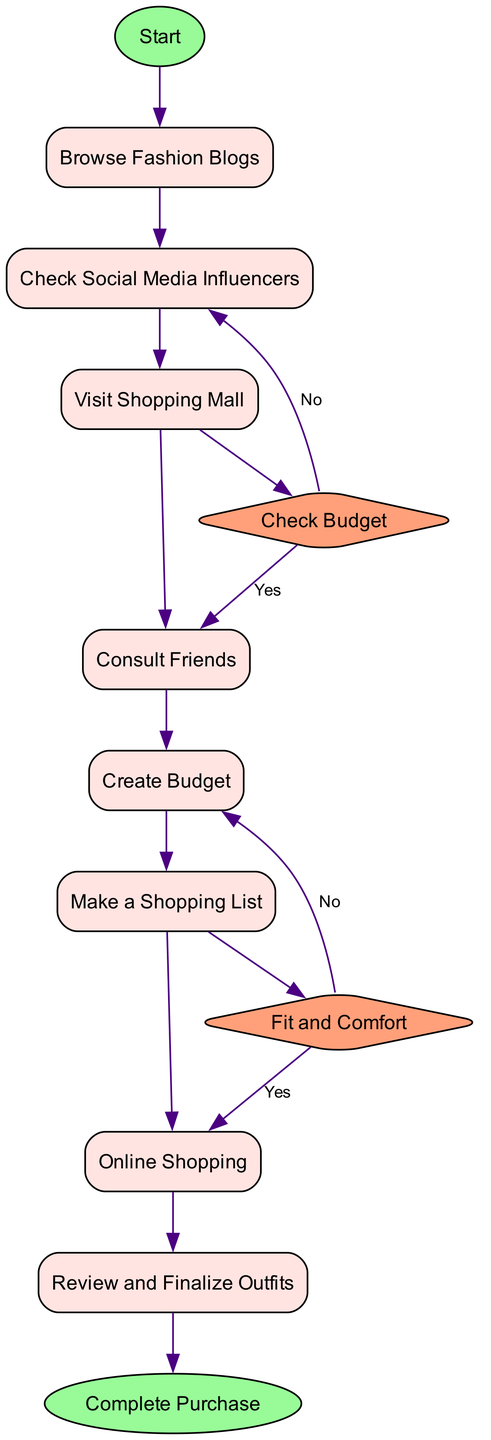What is the starting activity of the diagram? The diagram begins with a node labeled "Start," which indicates the initiation of the fashion shopping process. The first activity following the start node is "Browse Fashion Blogs."
Answer: Start How many activities are present in the diagram? The diagram lists a total of eight activities related to shopping for fashion-forward outfits, which include browsing blogs, checking social media, and more.
Answer: Eight What is the decision point illustrated in the diagram? There are two decision points mentioned, which are "Check Budget" and "Fit and Comfort." These points are depicted as diamonds in the diagram and require evaluation as part of the shopping process.
Answer: Check Budget, Fit and Comfort Which activity happens after visiting the shopping mall? After the "Visit Shopping Mall" activity, the next node in the diagram is "Consult Friends," indicating that consulting friends is the following step after checking out physical stores.
Answer: Consult Friends What happens if the answer is 'No' at the decision point "Check Budget"? If the answer is 'No' at the "Check Budget" decision point, the flow moves back to the previous activity, which is "Make a Shopping List," indicating that one needs to rethink their selections based on the budget constraints.
Answer: Make a Shopping List What is the last action before completing the purchase? The last action before reaching the "Complete Purchase" endpoint is "Review and Finalize Outfits." This step involves evaluating all purchased items to ensure that they meet expectations before finalizing the purchase.
Answer: Review and Finalize Outfits How many decision points are there in total? The diagram includes two decision points which direct the flow based on evaluations regarding budget and comfort of fitting.
Answer: Two What is the purpose of creating a budget in the shopping process? The purpose of creating a budget is to set a spending limit based on available funds to avoid overspending and prioritize essential items when shopping for outfits.
Answer: Set a spending limit What is the outcome after the last activity in the flow? The outcome after the last activity, "Review and Finalize Outfits," is reaching the "Complete Purchase" endpoint, which signifies that the shopping process has concluded with the finalization of the purchase.
Answer: Complete Purchase 